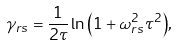<formula> <loc_0><loc_0><loc_500><loc_500>\gamma _ { r s } = \frac { 1 } { 2 \tau } \ln { \left ( { 1 + \omega _ { r s } ^ { 2 } \tau ^ { 2 } } \right ) } ,</formula> 